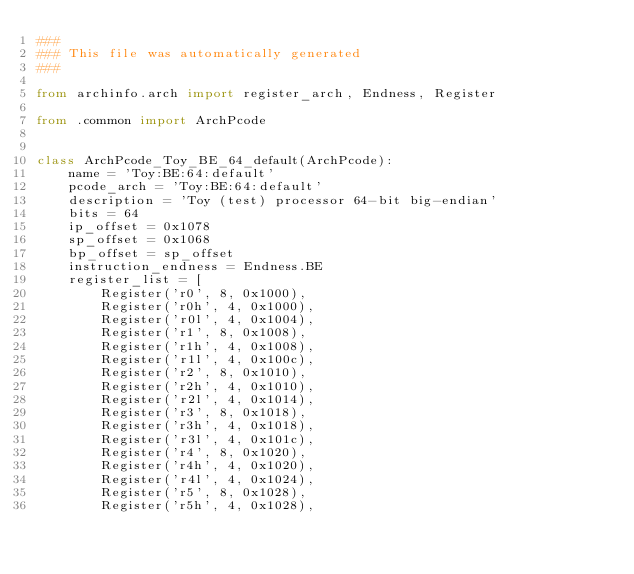Convert code to text. <code><loc_0><loc_0><loc_500><loc_500><_Python_>###
### This file was automatically generated
###

from archinfo.arch import register_arch, Endness, Register

from .common import ArchPcode


class ArchPcode_Toy_BE_64_default(ArchPcode):
    name = 'Toy:BE:64:default'
    pcode_arch = 'Toy:BE:64:default'
    description = 'Toy (test) processor 64-bit big-endian'
    bits = 64
    ip_offset = 0x1078
    sp_offset = 0x1068
    bp_offset = sp_offset
    instruction_endness = Endness.BE
    register_list = [
        Register('r0', 8, 0x1000),
        Register('r0h', 4, 0x1000),
        Register('r0l', 4, 0x1004),
        Register('r1', 8, 0x1008),
        Register('r1h', 4, 0x1008),
        Register('r1l', 4, 0x100c),
        Register('r2', 8, 0x1010),
        Register('r2h', 4, 0x1010),
        Register('r2l', 4, 0x1014),
        Register('r3', 8, 0x1018),
        Register('r3h', 4, 0x1018),
        Register('r3l', 4, 0x101c),
        Register('r4', 8, 0x1020),
        Register('r4h', 4, 0x1020),
        Register('r4l', 4, 0x1024),
        Register('r5', 8, 0x1028),
        Register('r5h', 4, 0x1028),</code> 